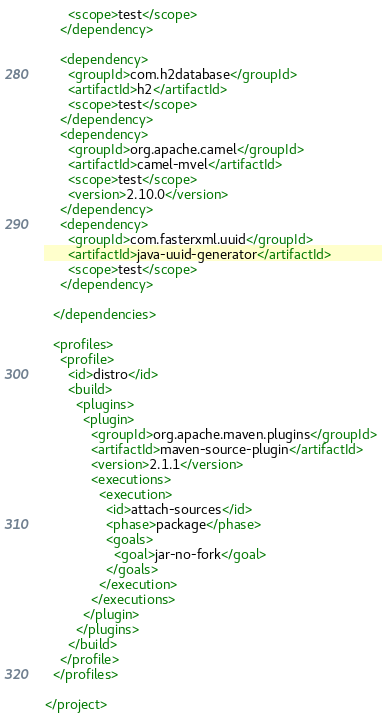Convert code to text. <code><loc_0><loc_0><loc_500><loc_500><_XML_>      <scope>test</scope>
    </dependency>

    <dependency>
      <groupId>com.h2database</groupId>
      <artifactId>h2</artifactId>
      <scope>test</scope>
    </dependency>
    <dependency>
      <groupId>org.apache.camel</groupId>
      <artifactId>camel-mvel</artifactId>
      <scope>test</scope>
      <version>2.10.0</version>
    </dependency>
    <dependency>
      <groupId>com.fasterxml.uuid</groupId>
      <artifactId>java-uuid-generator</artifactId>
      <scope>test</scope>
    </dependency>

  </dependencies>

  <profiles>
    <profile>
      <id>distro</id>
      <build>
        <plugins>
          <plugin>
            <groupId>org.apache.maven.plugins</groupId>
            <artifactId>maven-source-plugin</artifactId>
            <version>2.1.1</version>
            <executions>
              <execution>
                <id>attach-sources</id>
                <phase>package</phase>
                <goals>
                  <goal>jar-no-fork</goal>
                </goals>
              </execution>
            </executions>
          </plugin>
        </plugins>
      </build>
    </profile>
  </profiles>

</project>
</code> 